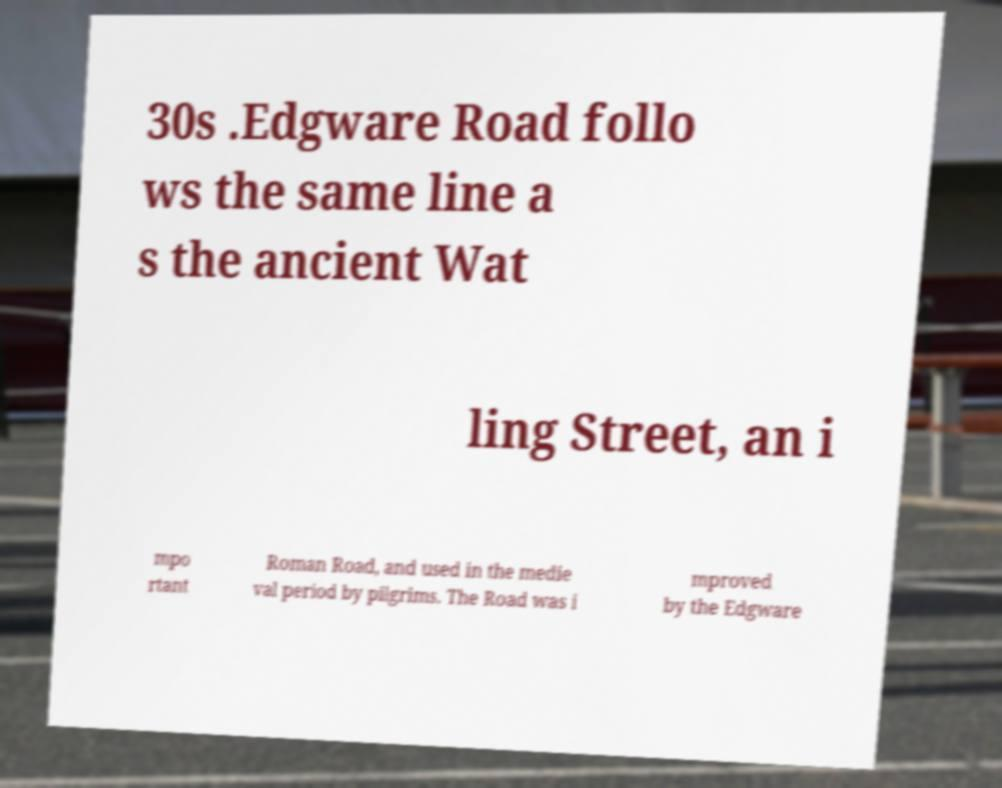What messages or text are displayed in this image? I need them in a readable, typed format. 30s .Edgware Road follo ws the same line a s the ancient Wat ling Street, an i mpo rtant Roman Road, and used in the medie val period by pilgrims. The Road was i mproved by the Edgware 